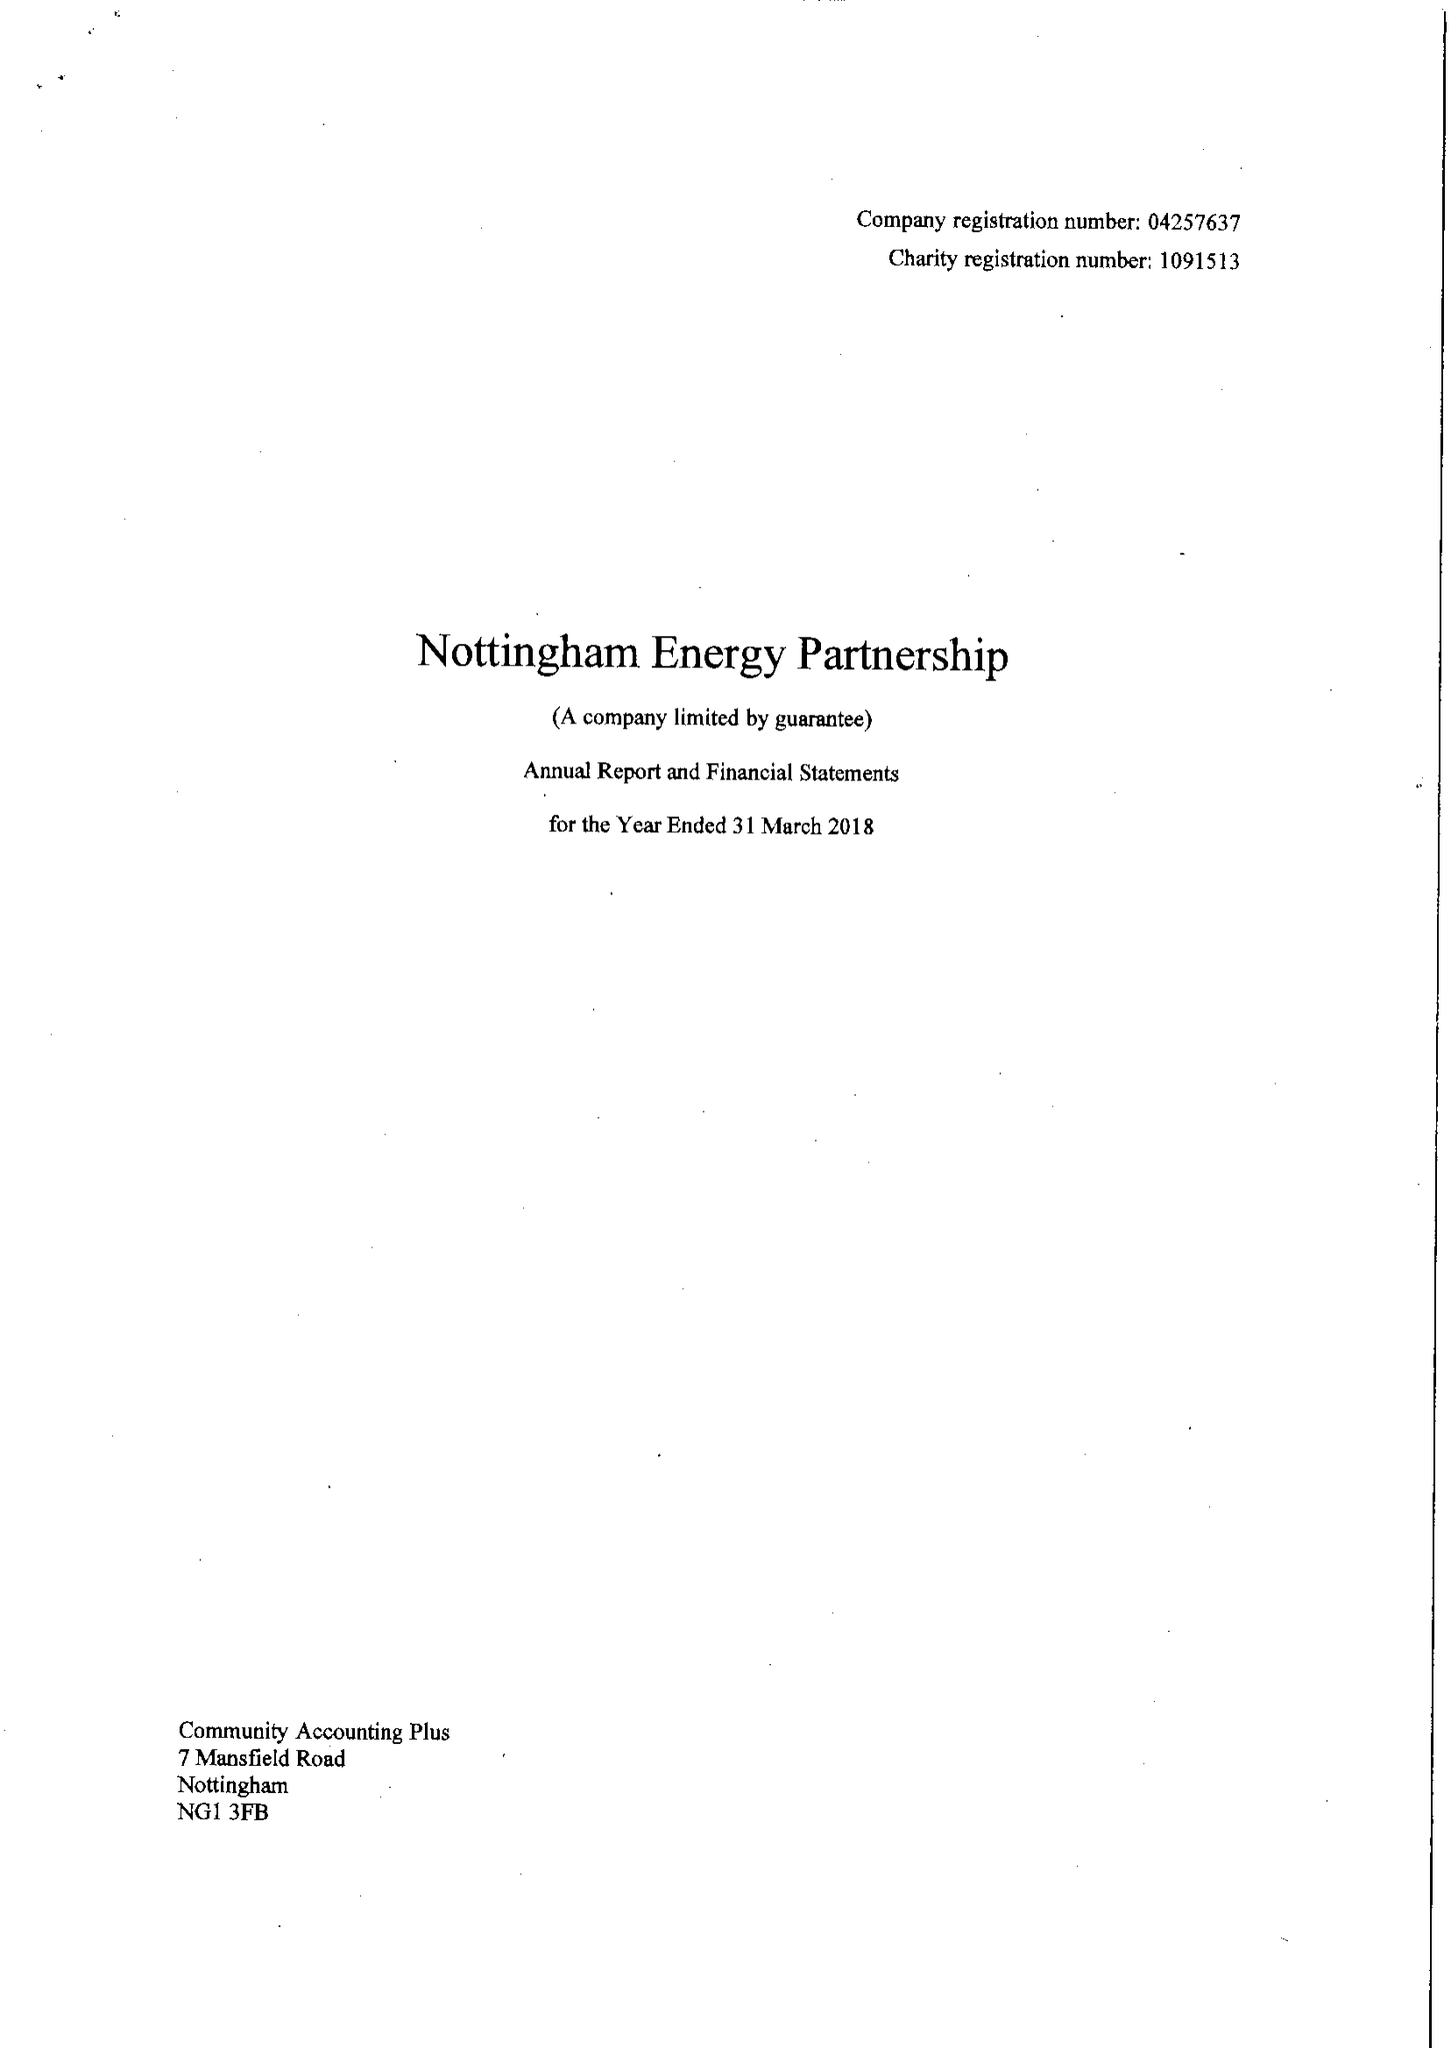What is the value for the spending_annually_in_british_pounds?
Answer the question using a single word or phrase. 555210.00 